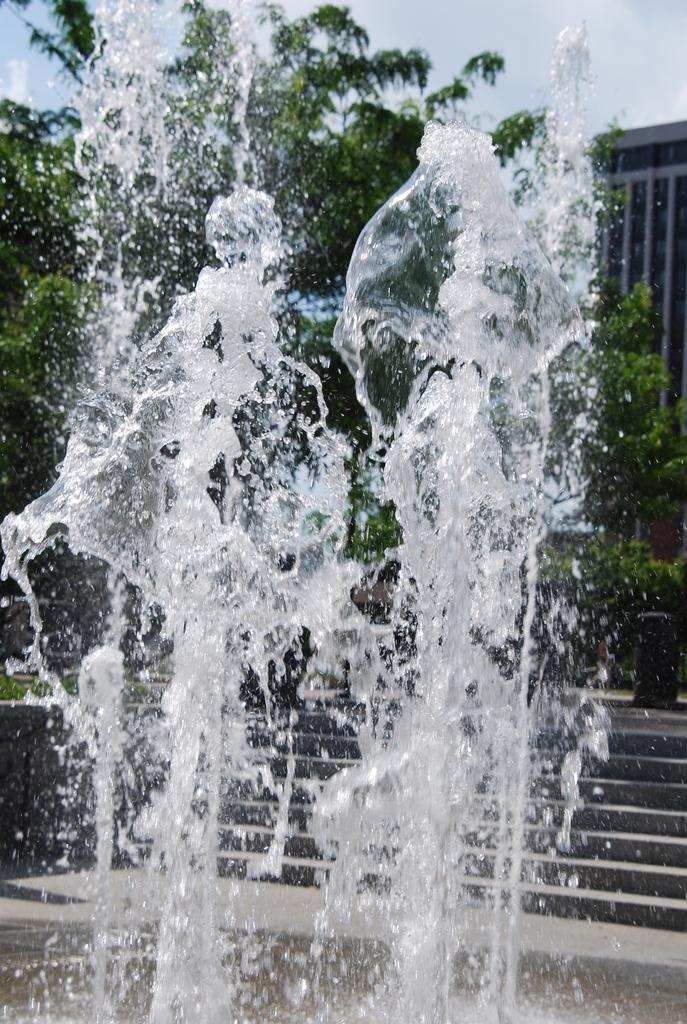What is the primary element present in the image? There is water in the image. What architectural feature can be seen in the image? There are steps in the image. What type of vegetation is visible in the image? There are trees in the image. What type of structure is present in the image? There is a building in the image. What can be seen in the background of the image? The sky is visible in the background of the image, and there are clouds in the sky. What type of jail is visible in the image? There is no jail present in the image. How are the clouds being sorted in the image? The clouds are not being sorted in the image; they are simply visible in the sky. 